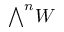<formula> <loc_0><loc_0><loc_500><loc_500>\bigwedge ^ { n } W</formula> 